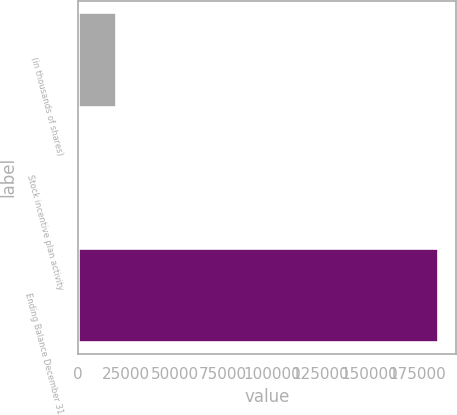Convert chart to OTSL. <chart><loc_0><loc_0><loc_500><loc_500><bar_chart><fcel>(in thousands of shares)<fcel>Stock incentive plan activity<fcel>Ending Balance December 31<nl><fcel>19796.1<fcel>1367<fcel>185658<nl></chart> 